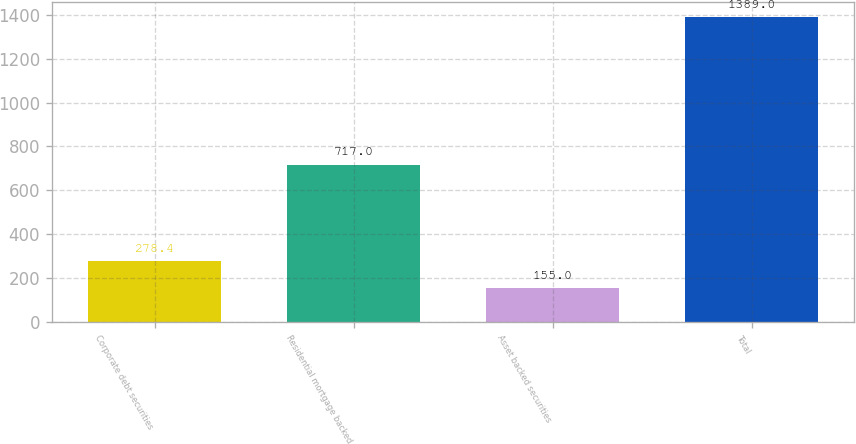Convert chart. <chart><loc_0><loc_0><loc_500><loc_500><bar_chart><fcel>Corporate debt securities<fcel>Residential mortgage backed<fcel>Asset backed securities<fcel>Total<nl><fcel>278.4<fcel>717<fcel>155<fcel>1389<nl></chart> 